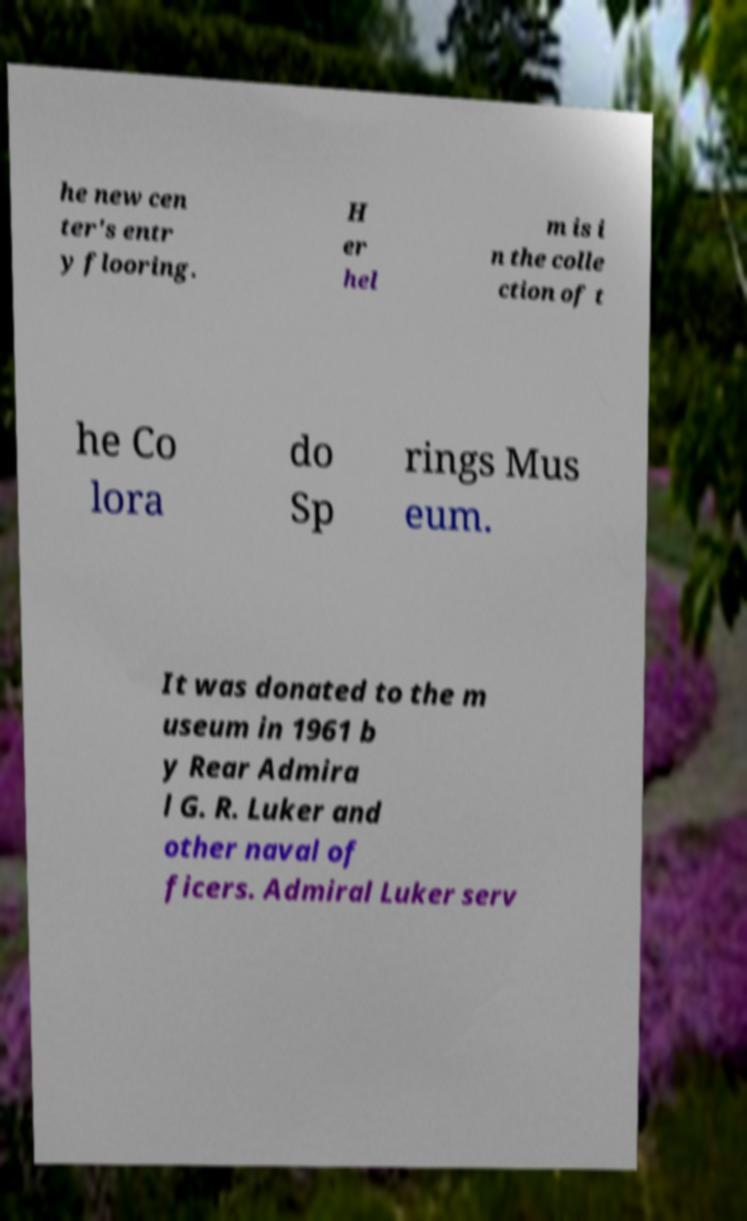Please read and relay the text visible in this image. What does it say? he new cen ter's entr y flooring. H er hel m is i n the colle ction of t he Co lora do Sp rings Mus eum. It was donated to the m useum in 1961 b y Rear Admira l G. R. Luker and other naval of ficers. Admiral Luker serv 